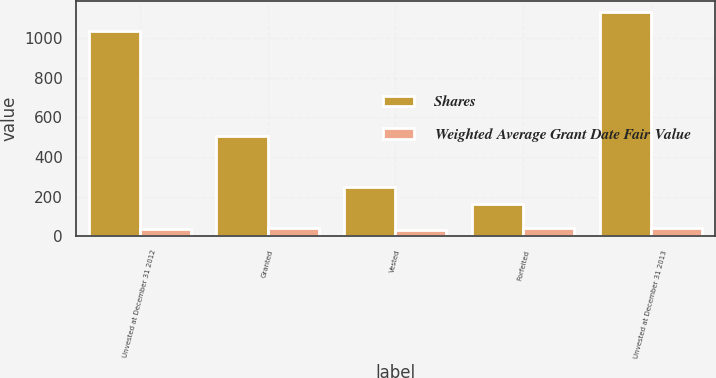Convert chart. <chart><loc_0><loc_0><loc_500><loc_500><stacked_bar_chart><ecel><fcel>Unvested at December 31 2012<fcel>Granted<fcel>Vested<fcel>Forfeited<fcel>Unvested at December 31 2013<nl><fcel>Shares<fcel>1034<fcel>506<fcel>248<fcel>161<fcel>1131<nl><fcel>Weighted Average Grant Date Fair Value<fcel>36.34<fcel>40.92<fcel>32.8<fcel>38.82<fcel>38.81<nl></chart> 